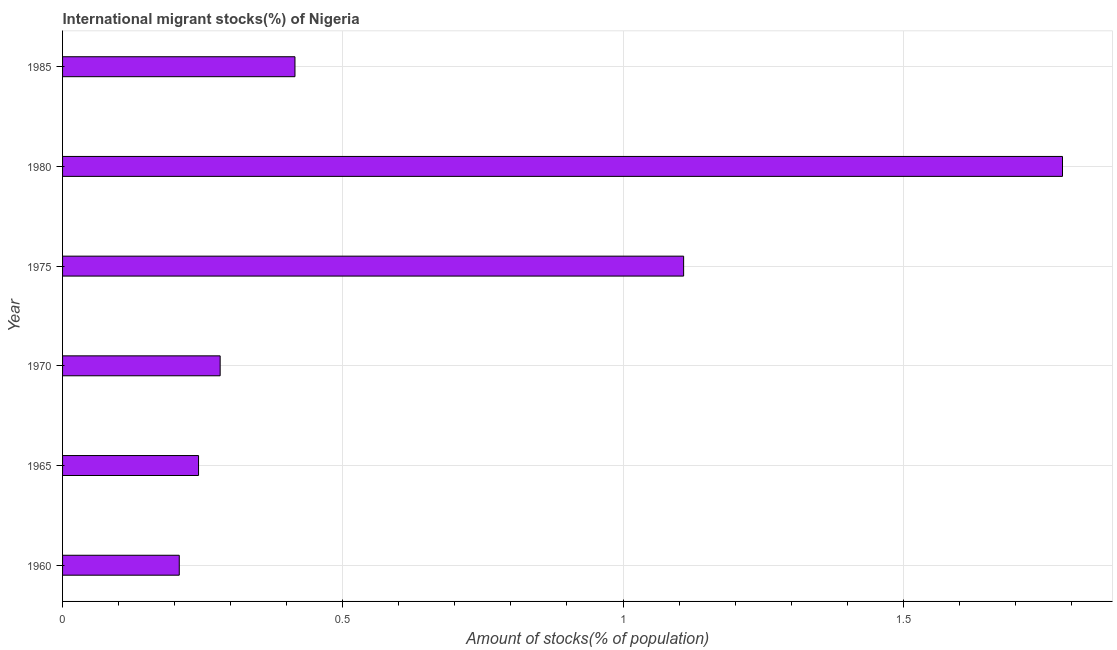Does the graph contain grids?
Your response must be concise. Yes. What is the title of the graph?
Make the answer very short. International migrant stocks(%) of Nigeria. What is the label or title of the X-axis?
Provide a succinct answer. Amount of stocks(% of population). What is the number of international migrant stocks in 1970?
Ensure brevity in your answer.  0.28. Across all years, what is the maximum number of international migrant stocks?
Provide a succinct answer. 1.78. Across all years, what is the minimum number of international migrant stocks?
Keep it short and to the point. 0.21. In which year was the number of international migrant stocks maximum?
Make the answer very short. 1980. In which year was the number of international migrant stocks minimum?
Your answer should be compact. 1960. What is the sum of the number of international migrant stocks?
Offer a very short reply. 4.04. What is the difference between the number of international migrant stocks in 1960 and 1965?
Make the answer very short. -0.03. What is the average number of international migrant stocks per year?
Ensure brevity in your answer.  0.67. What is the median number of international migrant stocks?
Your response must be concise. 0.35. In how many years, is the number of international migrant stocks greater than 1.7 %?
Offer a terse response. 1. Do a majority of the years between 1985 and 1960 (inclusive) have number of international migrant stocks greater than 1.6 %?
Offer a very short reply. Yes. What is the ratio of the number of international migrant stocks in 1970 to that in 1980?
Your answer should be very brief. 0.16. Is the difference between the number of international migrant stocks in 1980 and 1985 greater than the difference between any two years?
Make the answer very short. No. What is the difference between the highest and the second highest number of international migrant stocks?
Your answer should be very brief. 0.68. Is the sum of the number of international migrant stocks in 1975 and 1980 greater than the maximum number of international migrant stocks across all years?
Ensure brevity in your answer.  Yes. What is the difference between the highest and the lowest number of international migrant stocks?
Your answer should be very brief. 1.58. How many bars are there?
Make the answer very short. 6. How many years are there in the graph?
Your answer should be compact. 6. What is the difference between two consecutive major ticks on the X-axis?
Make the answer very short. 0.5. Are the values on the major ticks of X-axis written in scientific E-notation?
Offer a very short reply. No. What is the Amount of stocks(% of population) of 1960?
Your answer should be compact. 0.21. What is the Amount of stocks(% of population) of 1965?
Your answer should be very brief. 0.24. What is the Amount of stocks(% of population) of 1970?
Your response must be concise. 0.28. What is the Amount of stocks(% of population) in 1975?
Make the answer very short. 1.11. What is the Amount of stocks(% of population) in 1980?
Your answer should be compact. 1.78. What is the Amount of stocks(% of population) of 1985?
Your answer should be compact. 0.41. What is the difference between the Amount of stocks(% of population) in 1960 and 1965?
Make the answer very short. -0.03. What is the difference between the Amount of stocks(% of population) in 1960 and 1970?
Offer a very short reply. -0.07. What is the difference between the Amount of stocks(% of population) in 1960 and 1975?
Make the answer very short. -0.9. What is the difference between the Amount of stocks(% of population) in 1960 and 1980?
Offer a terse response. -1.58. What is the difference between the Amount of stocks(% of population) in 1960 and 1985?
Provide a succinct answer. -0.21. What is the difference between the Amount of stocks(% of population) in 1965 and 1970?
Offer a terse response. -0.04. What is the difference between the Amount of stocks(% of population) in 1965 and 1975?
Give a very brief answer. -0.87. What is the difference between the Amount of stocks(% of population) in 1965 and 1980?
Give a very brief answer. -1.54. What is the difference between the Amount of stocks(% of population) in 1965 and 1985?
Give a very brief answer. -0.17. What is the difference between the Amount of stocks(% of population) in 1970 and 1975?
Give a very brief answer. -0.83. What is the difference between the Amount of stocks(% of population) in 1970 and 1980?
Offer a terse response. -1.5. What is the difference between the Amount of stocks(% of population) in 1970 and 1985?
Offer a terse response. -0.13. What is the difference between the Amount of stocks(% of population) in 1975 and 1980?
Make the answer very short. -0.68. What is the difference between the Amount of stocks(% of population) in 1975 and 1985?
Give a very brief answer. 0.69. What is the difference between the Amount of stocks(% of population) in 1980 and 1985?
Keep it short and to the point. 1.37. What is the ratio of the Amount of stocks(% of population) in 1960 to that in 1965?
Ensure brevity in your answer.  0.86. What is the ratio of the Amount of stocks(% of population) in 1960 to that in 1970?
Your answer should be compact. 0.74. What is the ratio of the Amount of stocks(% of population) in 1960 to that in 1975?
Provide a short and direct response. 0.19. What is the ratio of the Amount of stocks(% of population) in 1960 to that in 1980?
Ensure brevity in your answer.  0.12. What is the ratio of the Amount of stocks(% of population) in 1960 to that in 1985?
Provide a short and direct response. 0.5. What is the ratio of the Amount of stocks(% of population) in 1965 to that in 1970?
Make the answer very short. 0.86. What is the ratio of the Amount of stocks(% of population) in 1965 to that in 1975?
Give a very brief answer. 0.22. What is the ratio of the Amount of stocks(% of population) in 1965 to that in 1980?
Offer a terse response. 0.14. What is the ratio of the Amount of stocks(% of population) in 1965 to that in 1985?
Your answer should be compact. 0.58. What is the ratio of the Amount of stocks(% of population) in 1970 to that in 1975?
Your answer should be compact. 0.25. What is the ratio of the Amount of stocks(% of population) in 1970 to that in 1980?
Offer a very short reply. 0.16. What is the ratio of the Amount of stocks(% of population) in 1970 to that in 1985?
Provide a short and direct response. 0.68. What is the ratio of the Amount of stocks(% of population) in 1975 to that in 1980?
Keep it short and to the point. 0.62. What is the ratio of the Amount of stocks(% of population) in 1975 to that in 1985?
Provide a short and direct response. 2.67. What is the ratio of the Amount of stocks(% of population) in 1980 to that in 1985?
Provide a succinct answer. 4.3. 